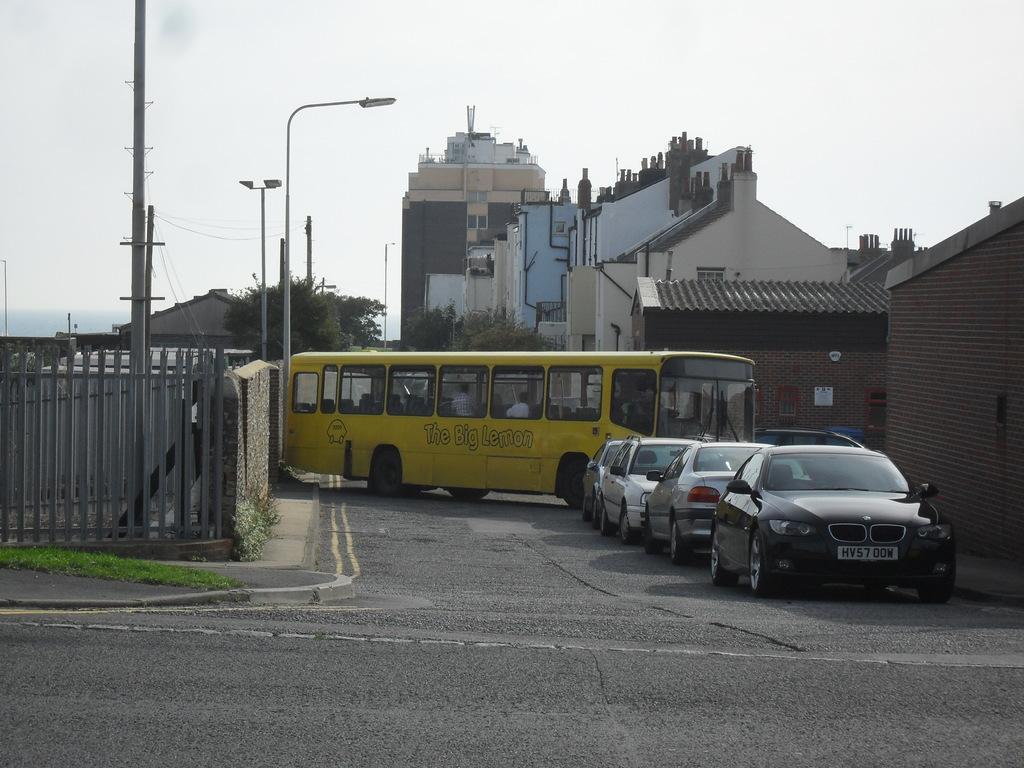Can you describe this image briefly? In this image there is a person on the road. Before it there are few cars. Few persons are inside the bus. Left side there is a fence to the wall. Behind there are few poles and street lights. Background there are few trees. Behind there are few buildings. Top of the image there is sky. 